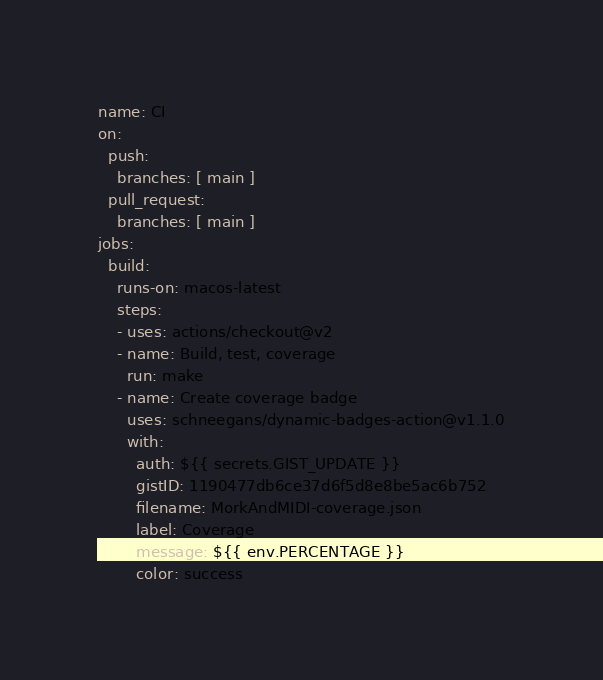Convert code to text. <code><loc_0><loc_0><loc_500><loc_500><_YAML_>name: CI
on:
  push:
    branches: [ main ]
  pull_request:
    branches: [ main ]
jobs:
  build:
    runs-on: macos-latest
    steps:
    - uses: actions/checkout@v2
    - name: Build, test, coverage
      run: make
    - name: Create coverage badge
      uses: schneegans/dynamic-badges-action@v1.1.0
      with:
        auth: ${{ secrets.GIST_UPDATE }}
        gistID: 1190477db6ce37d6f5d8e8be5ac6b752
        filename: MorkAndMIDI-coverage.json
        label: Coverage
        message: ${{ env.PERCENTAGE }}
        color: success
</code> 